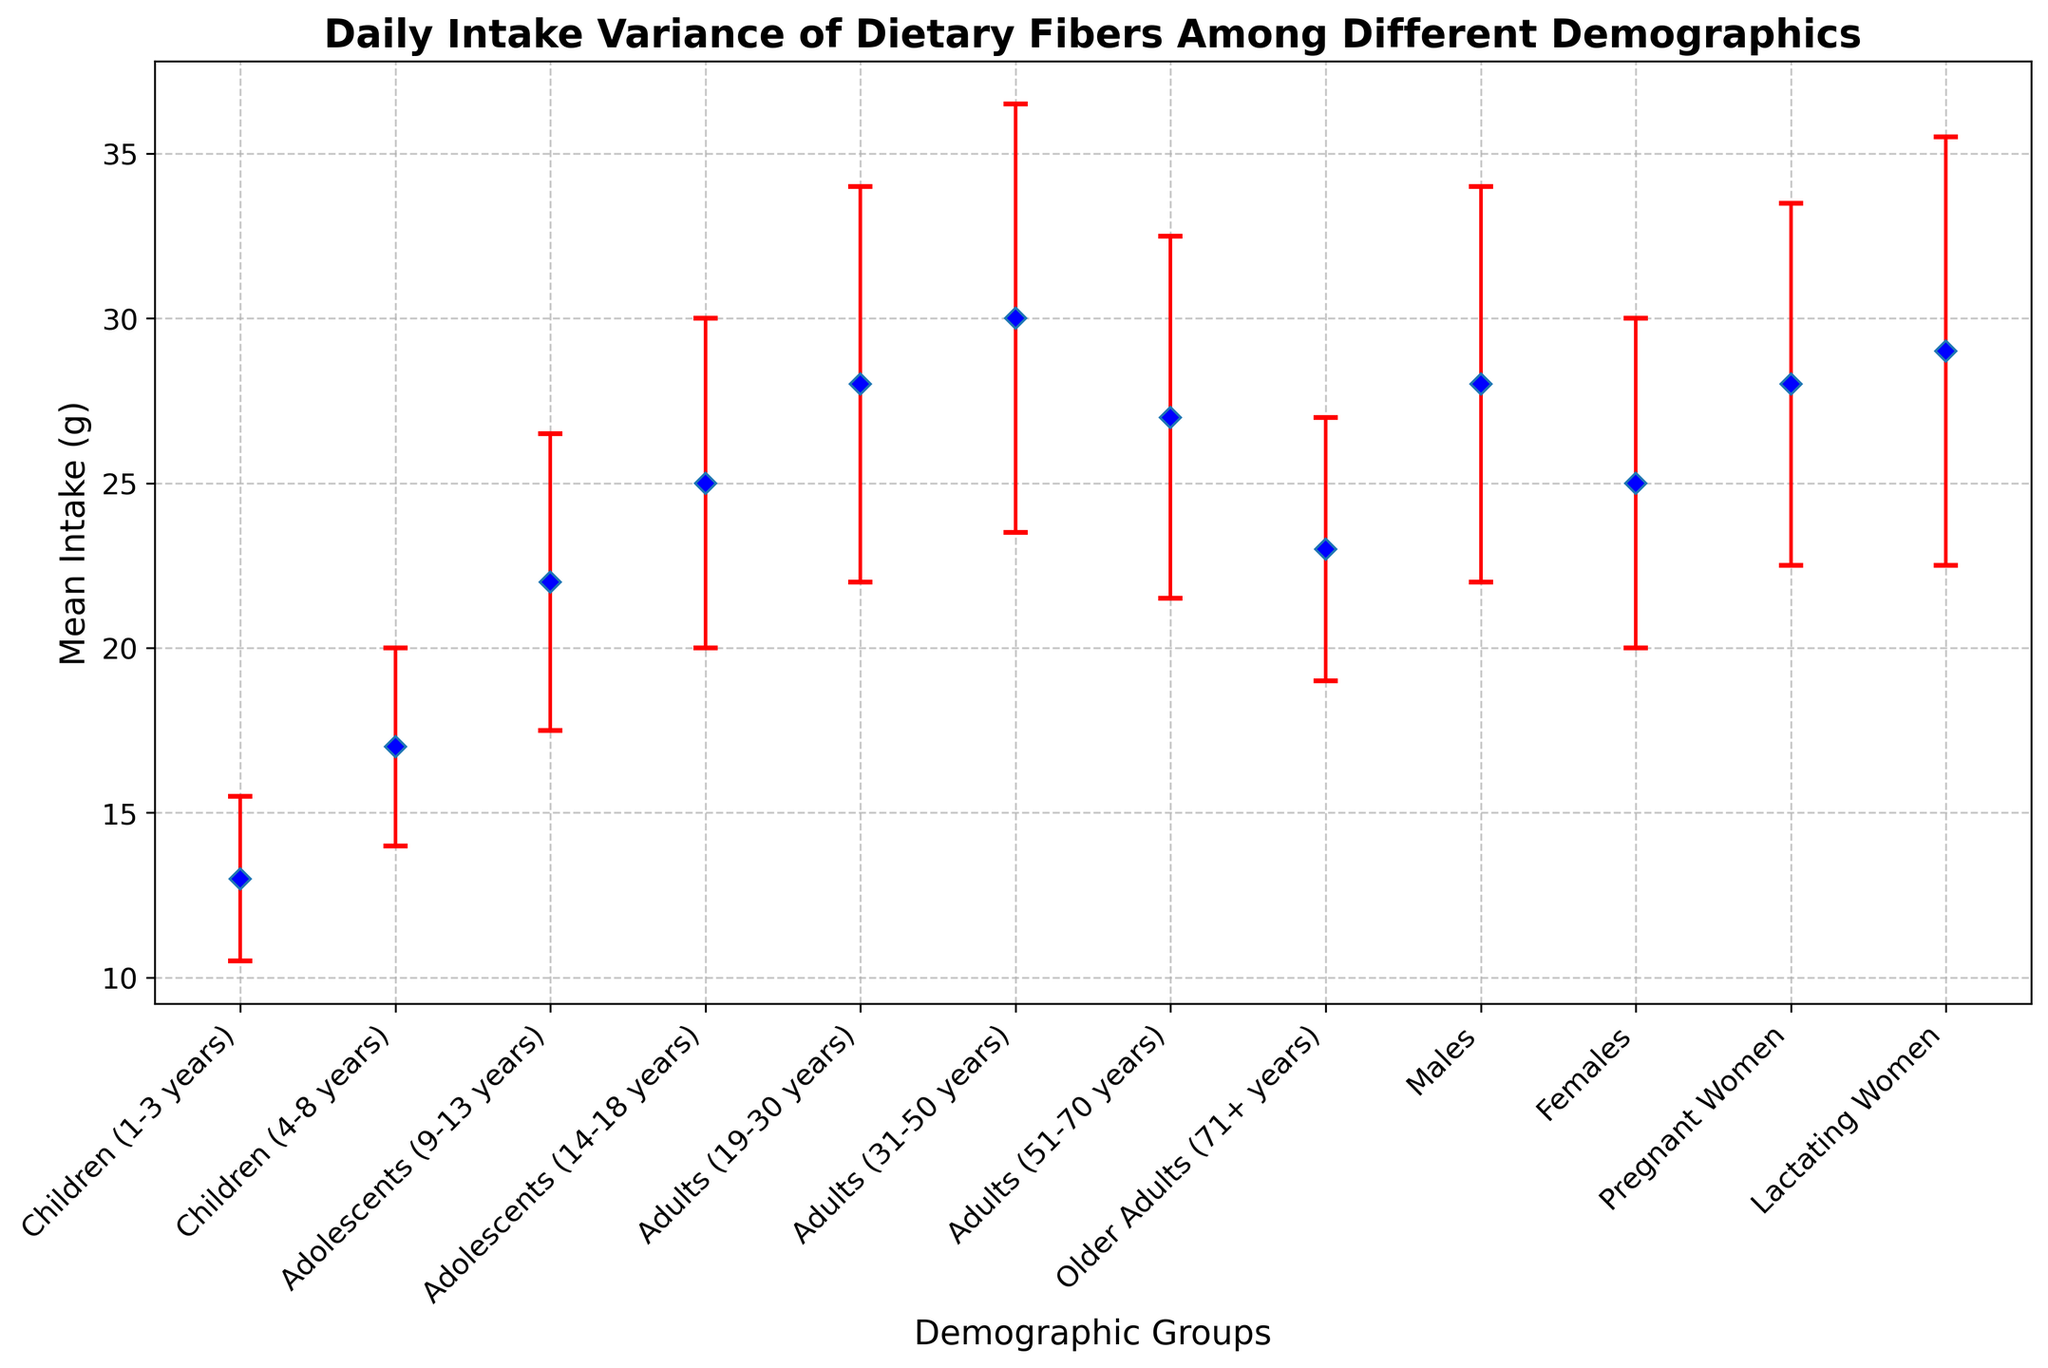Which demographic group has the highest mean intake of dietary fibers? From the plot, look for the demographic group with the highest mean intake value represented by the blue markers on the error bars.
Answer: Adults (31-50 years) Which demographic group has the lowest mean intake of dietary fibers? Identify the group with the lowest mean intake value on the plot.
Answer: Children (1-3 years) What is the difference in the mean intake of dietary fibers between Adults (31-50 years) and Children (1-3 years)? Subtract the mean intake of Children (1-3 years) from the mean intake of Adults (31-50 years) (30 - 13).
Answer: 17 grams Which demographic groups have a mean intake of dietary fibers of 28 grams? Locate the demographic groups marked with a mean intake of 28 grams on the plot.
Answer: Adults (19-30 years) and Males What is the range of mean dietary fiber intake among all demographic groups? Find the highest and lowest mean intake values, then calculate the range (30 - 13).
Answer: 17 grams What is the average standard deviation of dietary fiber intake across all demographic groups? Sum all standard deviations and divide by the number of groups. (2.5 + 3.0 + 4.5 + 5.0 + 6.0 + 6.5 + 5.5 + 4.0 + 6.0 + 5.0 + 5.5 + 6.5) / 12 = 5.08
Answer: 5.08 grams Which demographic groups have similar mean intakes of dietary fibers, within a 1-gram difference? Compare the mean intake values and identify groups that are within 1 gram difference.
Answer: Adults (19-30 years) and Pregnant Women Between Females and Males, which group shows a higher variance in daily fiber intake? Compare the lengths of the error bars for Females and Males; the one with longer error bars has higher variance.
Answer: Males How does the mean intake of dietary fibers for Lactating Women compare to that of Adults (51-70 years)? Compare the mean intake values of the two groups (Lactating Women = 29 grams, Adults (51-70 years) = 27 grams).
Answer: Lactating Women have a higher mean intake What's the total mean intake of dietary fibers for Adolescents (both age groups combined)? Add the mean intakes of Adolescents (14-18 years) and Adolescents (9-13 years) (25 + 22).
Answer: 47 grams 